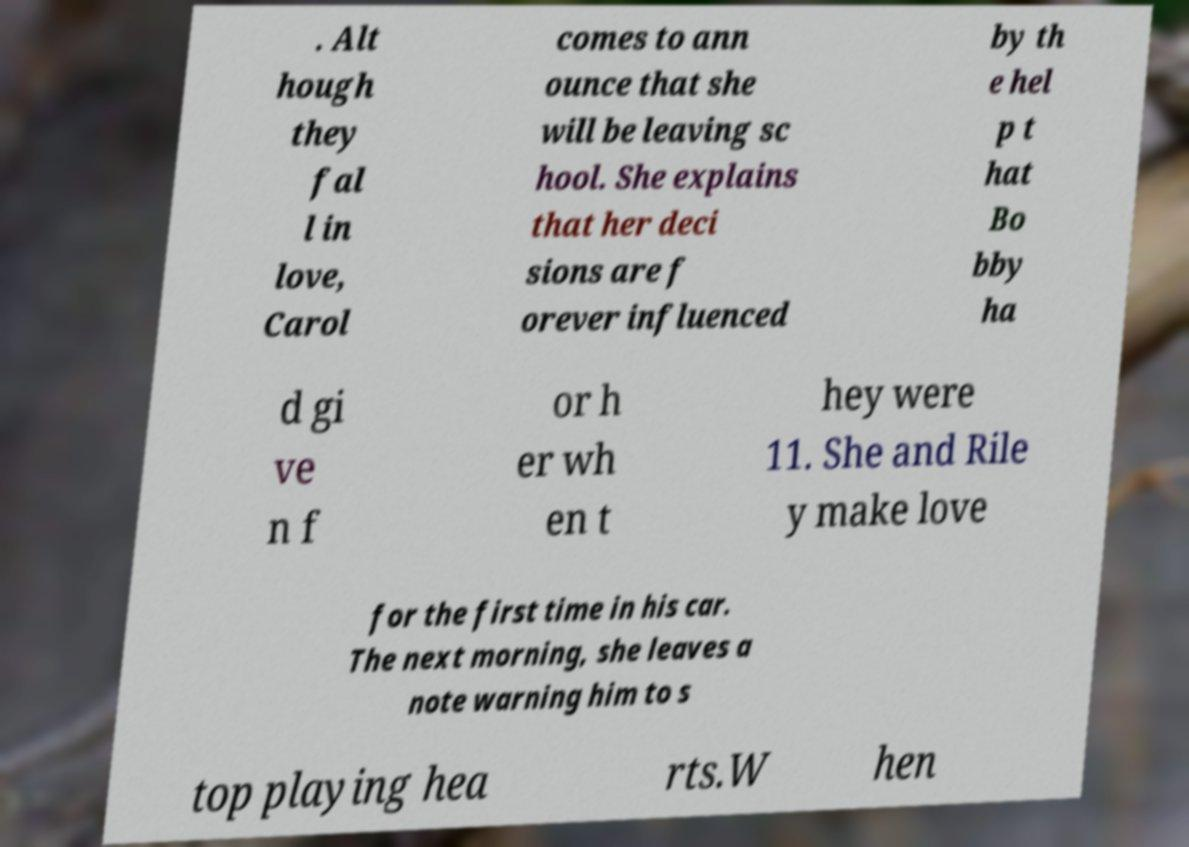Please read and relay the text visible in this image. What does it say? . Alt hough they fal l in love, Carol comes to ann ounce that she will be leaving sc hool. She explains that her deci sions are f orever influenced by th e hel p t hat Bo bby ha d gi ve n f or h er wh en t hey were 11. She and Rile y make love for the first time in his car. The next morning, she leaves a note warning him to s top playing hea rts.W hen 